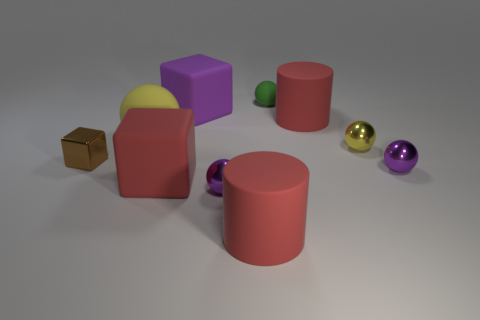Subtract all large cubes. How many cubes are left? 1 Subtract all purple balls. How many balls are left? 3 Subtract 2 spheres. How many spheres are left? 3 Subtract all large red metal balls. Subtract all cubes. How many objects are left? 7 Add 2 small rubber balls. How many small rubber balls are left? 3 Add 7 tiny red matte blocks. How many tiny red matte blocks exist? 7 Subtract 0 cyan balls. How many objects are left? 10 Subtract all cubes. How many objects are left? 7 Subtract all brown spheres. Subtract all red blocks. How many spheres are left? 5 Subtract all yellow balls. How many yellow cylinders are left? 0 